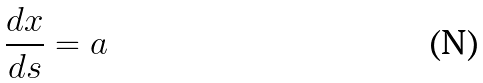Convert formula to latex. <formula><loc_0><loc_0><loc_500><loc_500>\frac { d x } { d s } = a</formula> 